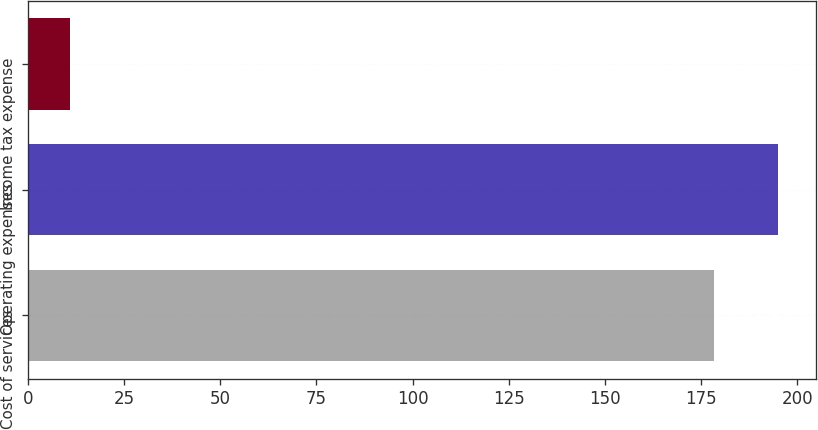Convert chart to OTSL. <chart><loc_0><loc_0><loc_500><loc_500><bar_chart><fcel>Cost of services<fcel>Operating expenses<fcel>Income tax expense<nl><fcel>178.4<fcel>195.14<fcel>11<nl></chart> 